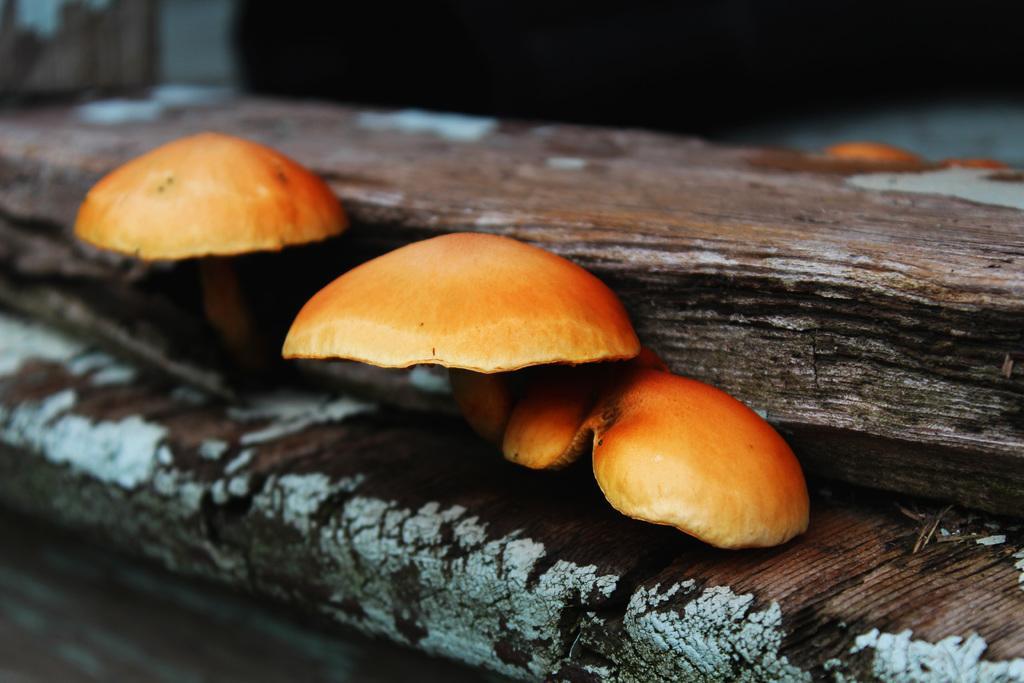Could you give a brief overview of what you see in this image? In the image we can see a wooden log and on it there are mushrooms and the background is blurred. 